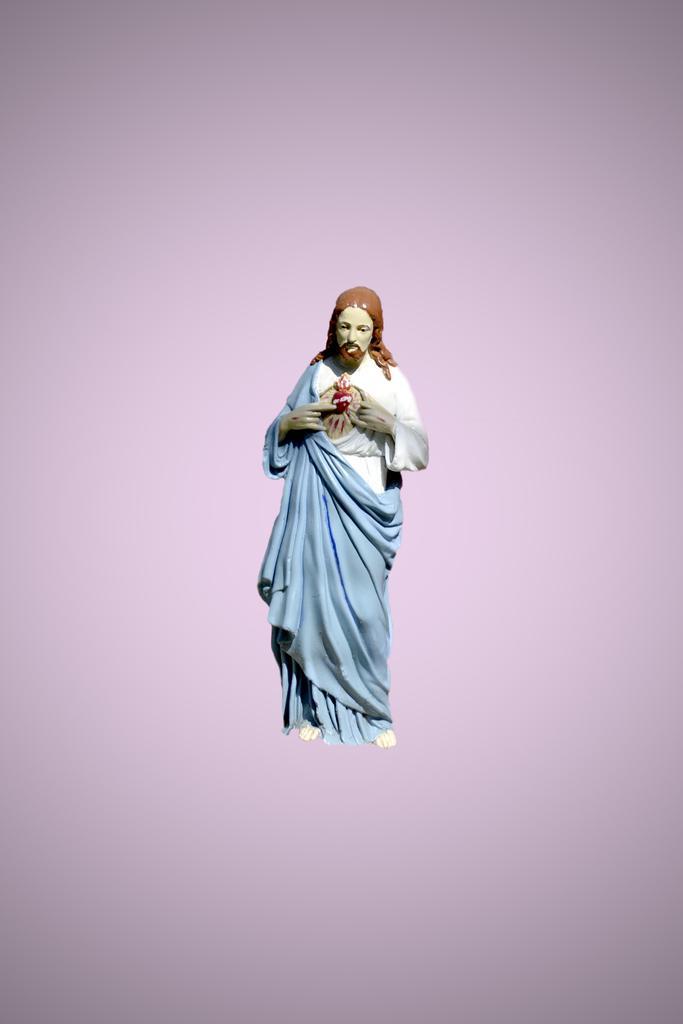How would you summarize this image in a sentence or two? In the foreground of this animated image, there is a sculpture with lilac background. 